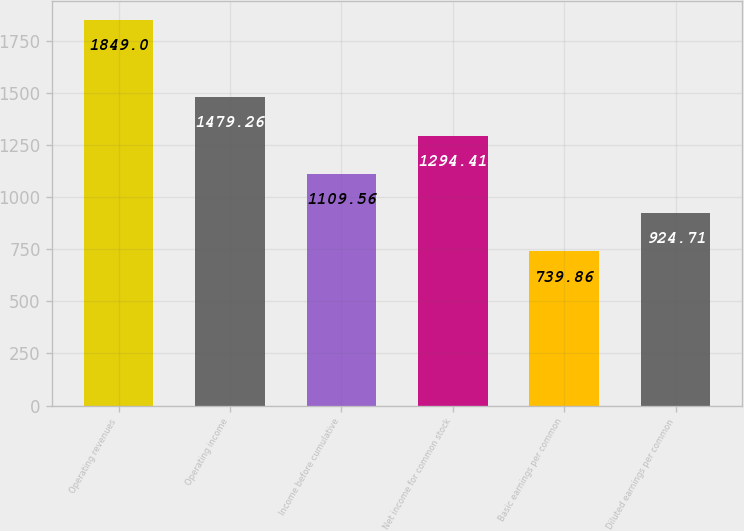Convert chart. <chart><loc_0><loc_0><loc_500><loc_500><bar_chart><fcel>Operating revenues<fcel>Operating income<fcel>Income before cumulative<fcel>Net income for common stock<fcel>Basic earnings per common<fcel>Diluted earnings per common<nl><fcel>1849<fcel>1479.26<fcel>1109.56<fcel>1294.41<fcel>739.86<fcel>924.71<nl></chart> 